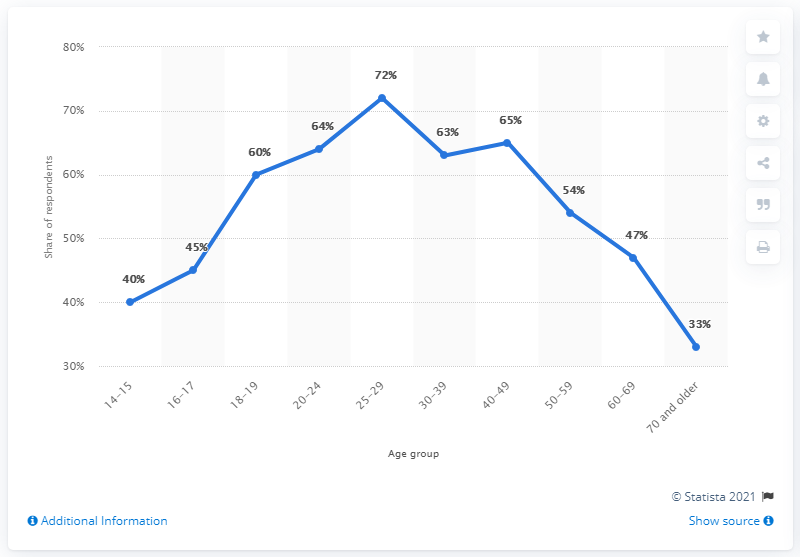Mention a couple of crucial points in this snapshot. The average of respondents under the age of 30 is 56.2. The age group with the highest percentage of respondents is 25-29 year olds. 